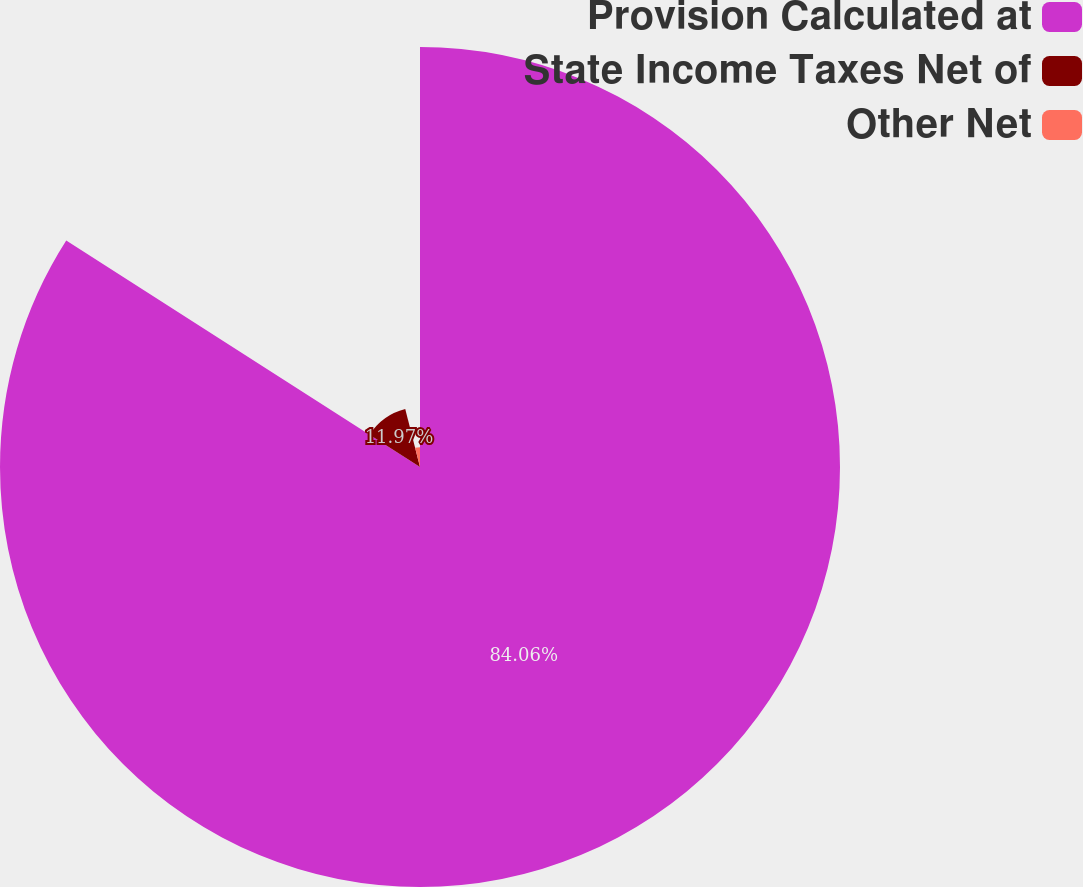Convert chart to OTSL. <chart><loc_0><loc_0><loc_500><loc_500><pie_chart><fcel>Provision Calculated at<fcel>State Income Taxes Net of<fcel>Other Net<nl><fcel>84.06%<fcel>11.97%<fcel>3.97%<nl></chart> 